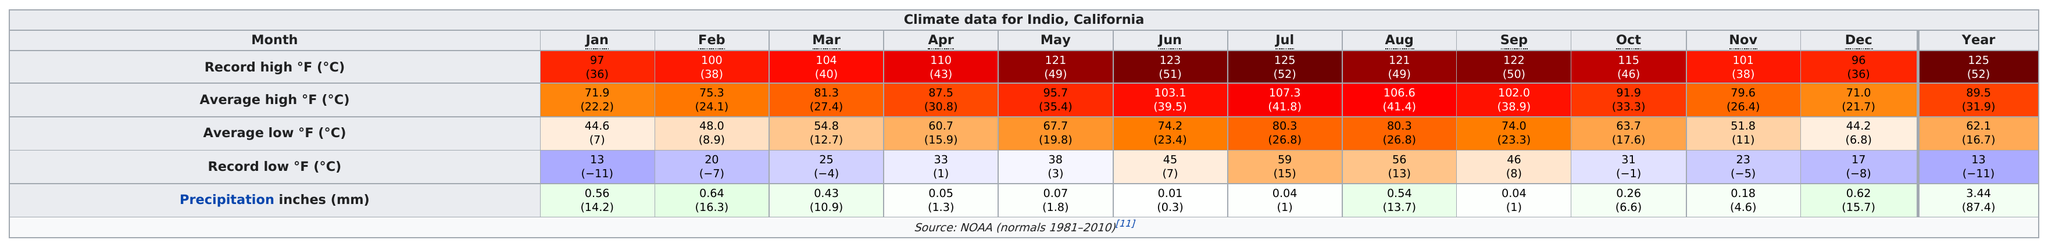Point out several critical features in this image. The highest recorded temperature in the Coachella Valley was 125 degrees. During the month of January, there were seven months that set record lows below freezing. For the past four months, the average monthly temperature was consistently 100 degrees Fahrenheit or higher. 